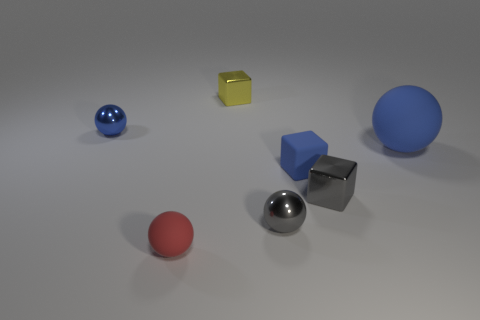If these objects were part of a game, what kind of game could it be and how would it be played? If the objects were part of a game, it could be a strategy puzzle game where each sphere and cube represents different elements or resources. The game could involve moving these pieces into optimal positions to achieve certain goals, like forming patterns or sequences based on their colors and shapes. That sounds intriguing! Can you also suggest what the rules of this game might be? Certainly! One rule could be that each turn, a player can move one object one space in any direction, but the spheres can only move in a straight line, while the cubes can move one space diagonally as well. The objective might be to align the objects so that all spheres form a line with the cubes at the ends, representing a completed circuit or connection. 